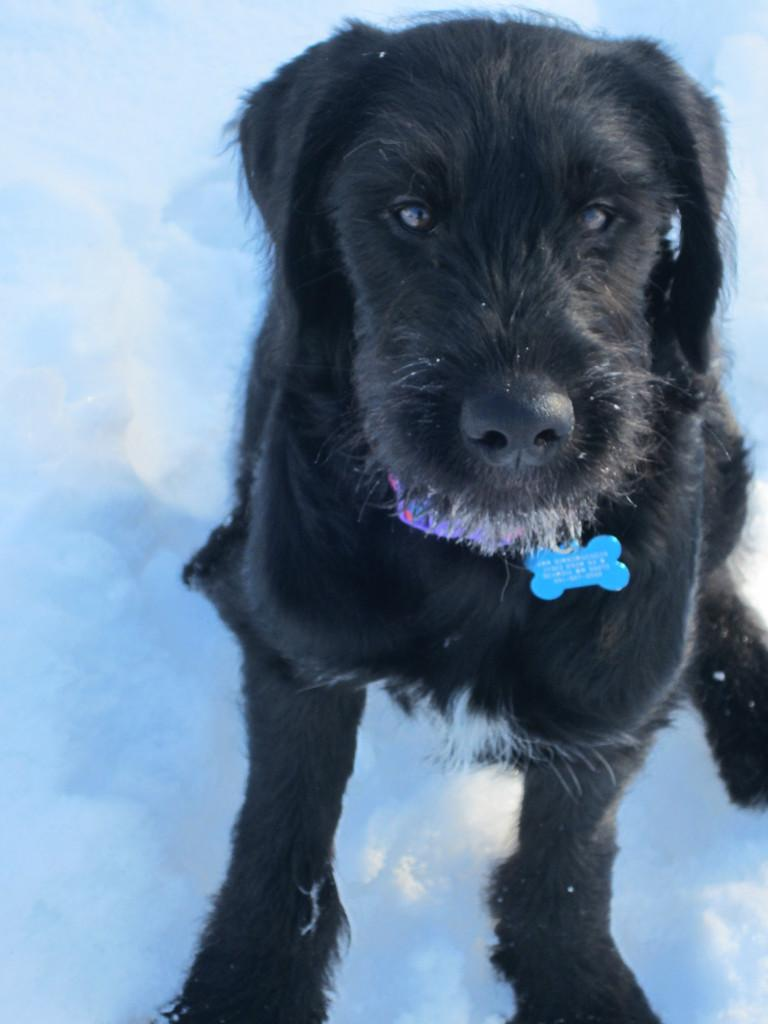What type of animal is in the image? There is a black dog in the image. Where is the dog positioned in relation to the viewer? The dog is in front of the viewer. What is the dog wearing around its neck? The dog is wearing a collar around its neck. What type of terrain is the dog standing on? The dog is on the snow. What chess piece does the dog represent in the image? There is no chess piece or game of chess present in the image; it features a black dog on the snow. What type of crack is visible on the dog's fur in the image? There is no crack visible on the dog's fur in the image. 